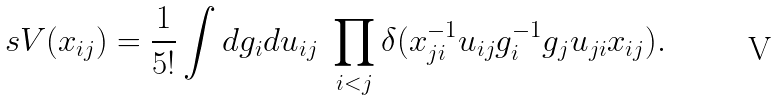Convert formula to latex. <formula><loc_0><loc_0><loc_500><loc_500>\ s V ( x _ { i j } ) = \frac { 1 } { 5 ! } \int d g _ { i } d u _ { i j } \ \prod _ { i < j } \delta ( x ^ { - 1 } _ { j i } u _ { i j } g ^ { - 1 } _ { i } g _ { j } u _ { j i } x _ { i j } ) .</formula> 